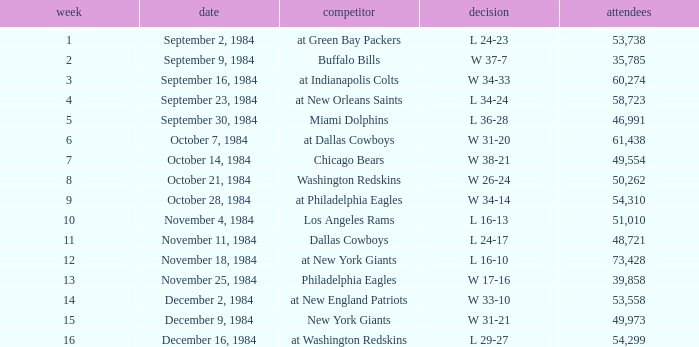What is the sum of attendance when the result was l 16-13? 51010.0. 